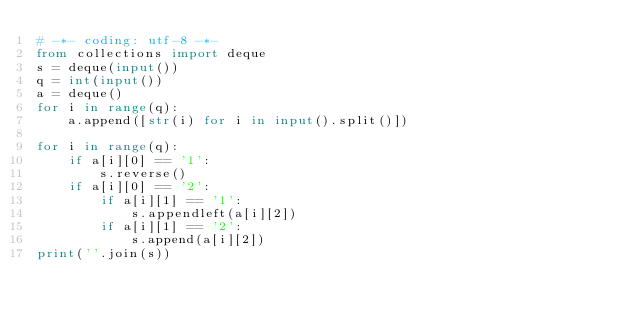<code> <loc_0><loc_0><loc_500><loc_500><_Python_># -*- coding: utf-8 -*-
from collections import deque
s = deque(input())
q = int(input())
a = deque()
for i in range(q):
    a.append([str(i) for i in input().split()])

for i in range(q):
    if a[i][0] == '1':
        s.reverse()
    if a[i][0] == '2':
        if a[i][1] == '1':
            s.appendleft(a[i][2])
        if a[i][1] == '2':
            s.append(a[i][2])
print(''.join(s))
</code> 